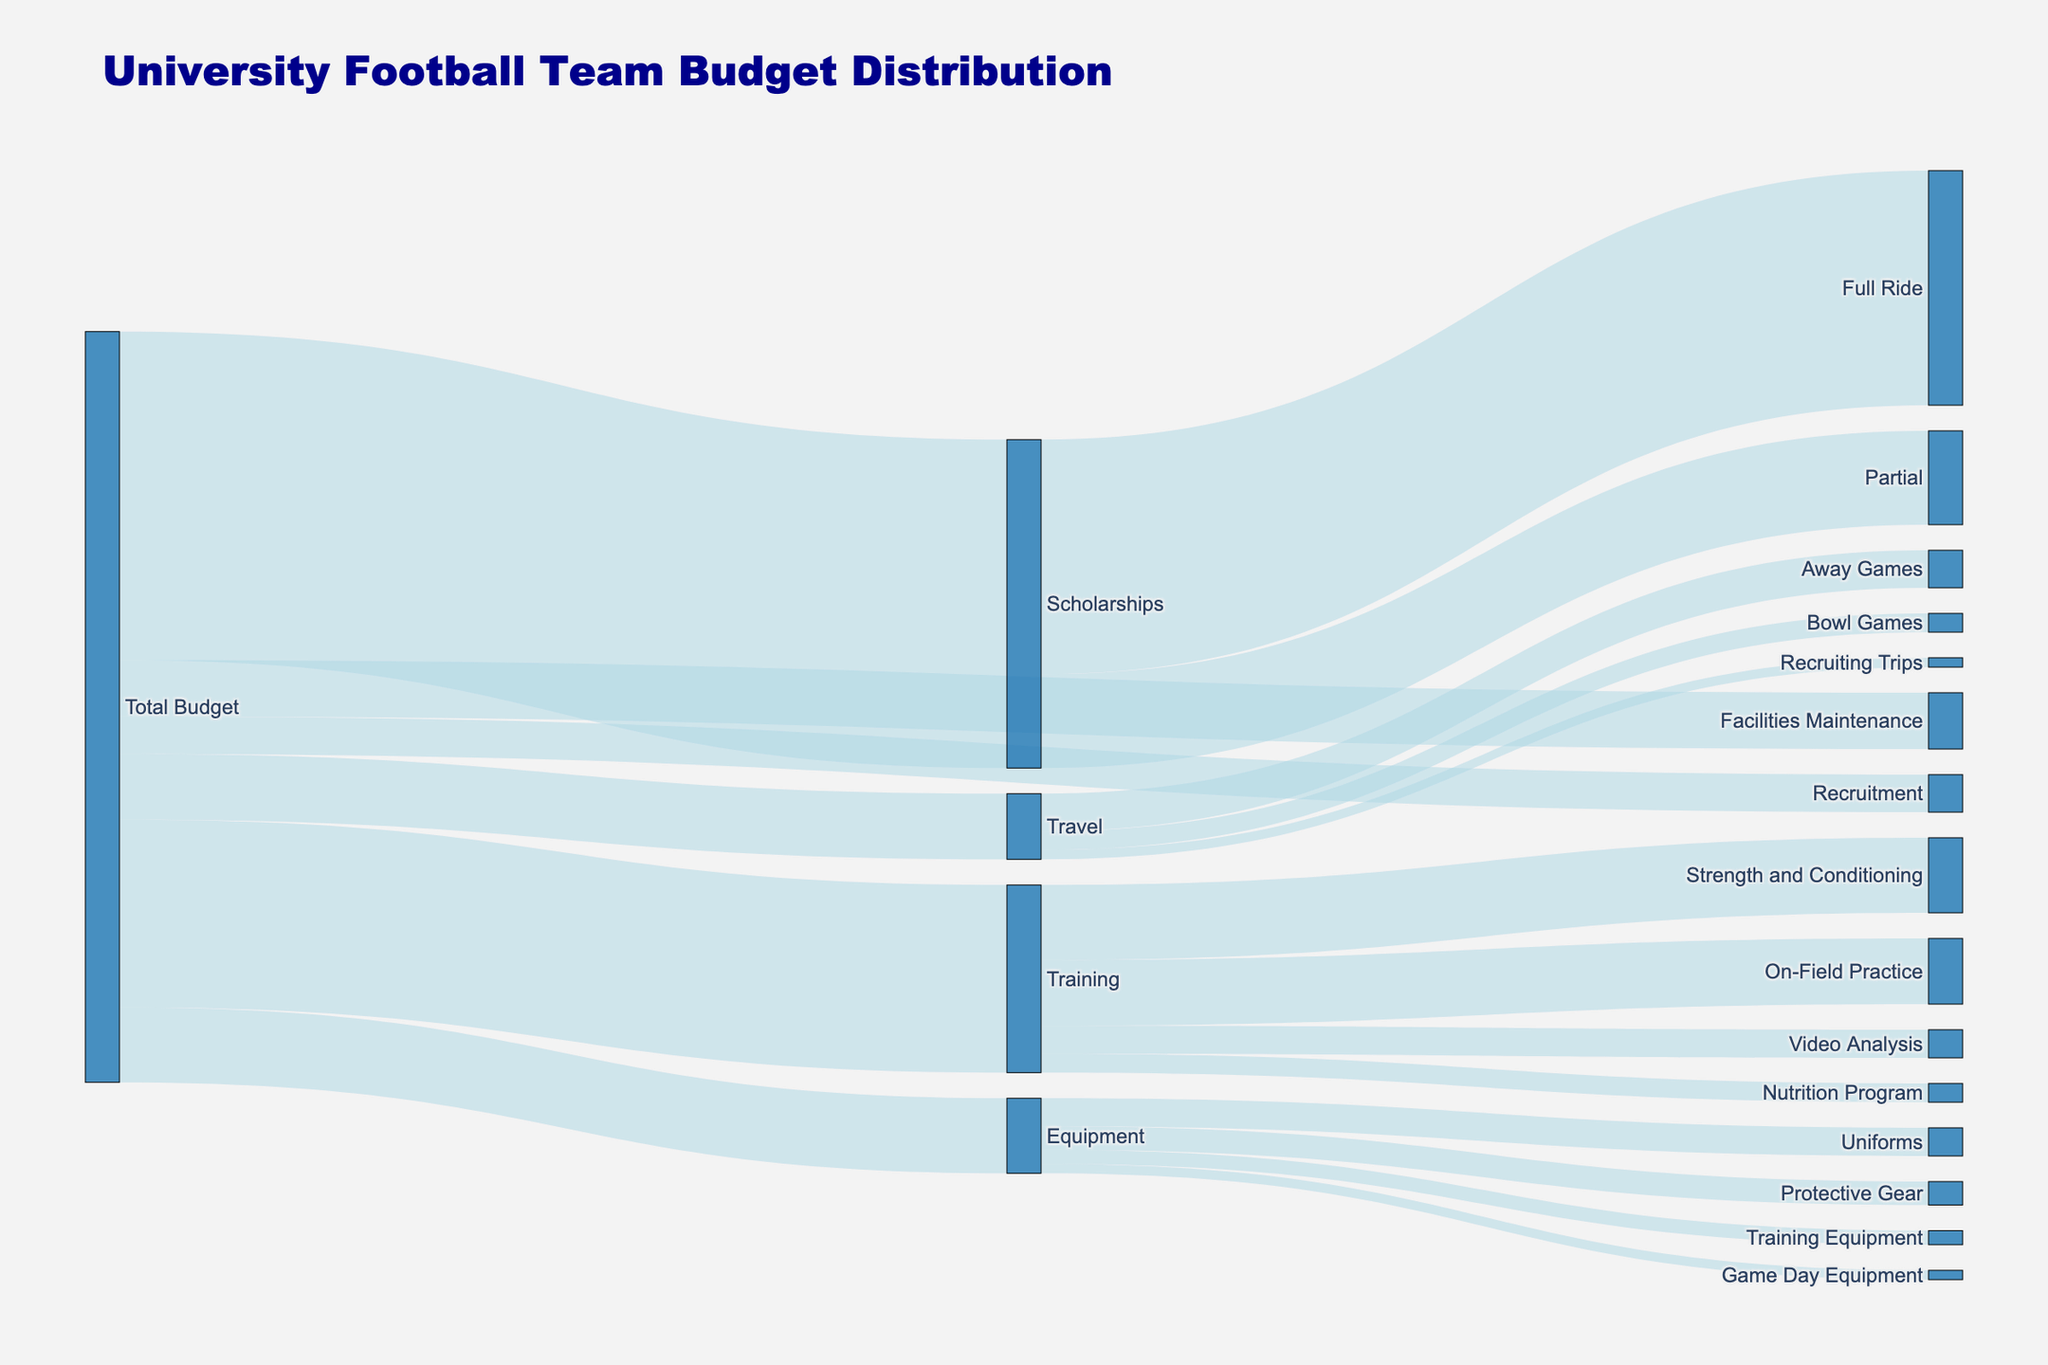what is the title of the figure? The title of the figure is located at the top, and it's usually the largest text to indicate the main topic of the visualization.
Answer: University Football Team Budget Distribution what expense category receives the highest budget allocation? By looking at the width of the flows coming from the "Total Budget" node, the largest flow represents the highest budget allocation.
Answer: Scholarships which subcategory under Scholarships receives more budget, Full Ride or Partial? We compare the width of the flows coming from the "Scholarships" node to "Full Ride" and "Partial", the wider flow indicates a higher value.
Answer: Full Ride which has a larger budget, Equipment or Travel? Compare the widths of the flows coming from the "Total Budget" node to "Equipment" and "Travel".
Answer: Equipment how much budget is allocated to Facilities Maintenance? Look at the value associated with the flow from "Total Budget" to "Facilities Maintenance".
Answer: 600000 which subcategory under Equipment receives the smallest budget allocation? Analyze the flows coming from the "Equipment" node, the narrowest flow represents the smallest budget allocation.
Answer: Game Day Equipment how does the budget for Away Games compare to Bowl Games under Travel? Compare the widths of the flows emanating from "Travel" to "Away Games" and "Bowl Games". The wider flow has a higher budget.
Answer: Away Games 